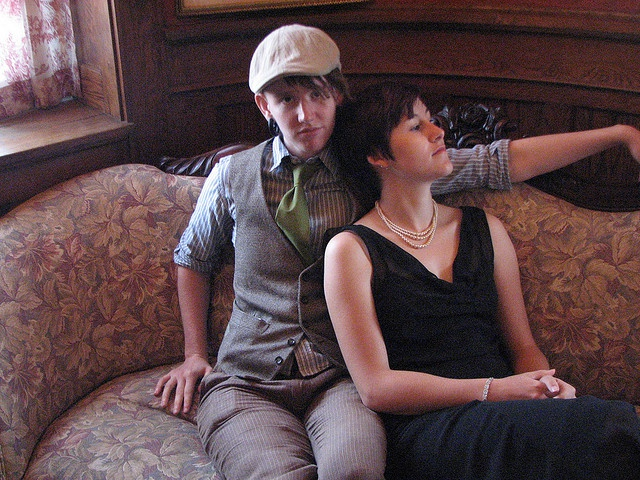Describe the objects in this image and their specific colors. I can see couch in pink, maroon, and brown tones, people in pink, black, gray, darkgray, and brown tones, people in pink, black, brown, and lightpink tones, and tie in pink, black, gray, and darkgreen tones in this image. 